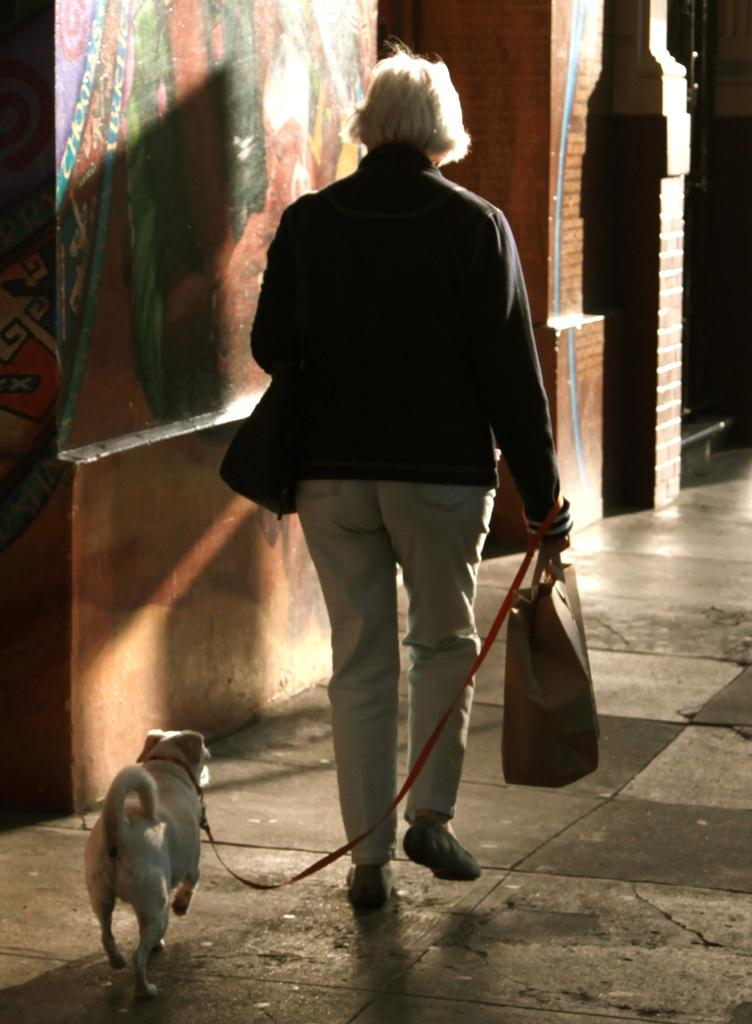What is the person in the image doing? The person is walking slowly. What is the person carrying on their body? The person is wearing a bag. Does the person have any pets with them? Yes, the person has a dog thread. What can be seen in the background of the image? There is a red wall brick and a road in the background. How many jellyfish are swimming in the background of the image? There are no jellyfish present in the image; it features a person walking with a dog thread and a red wall brick in the background. What type of coal is being used to fuel the person's movement in the image? There is no coal present in the image, and the person's movement is not fueled by coal. 